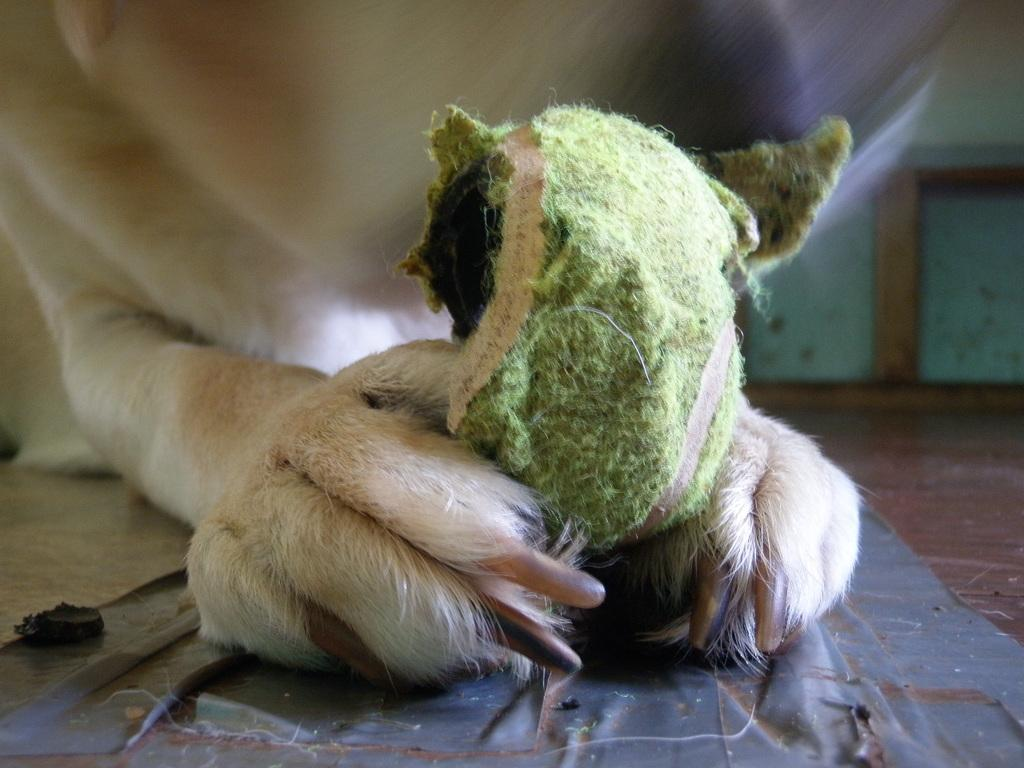What animal is in the front of the image? There is a dog in the front of the image. What object is present in the image? There is a ball in the image. What can be seen in the background of the image? There is a wall in the background of the image. Where is the shelf located in the image? There is no shelf present in the image. Can you hear the dog barking in the image? The image is a still picture, so it does not contain any sound, including the dog barking. 